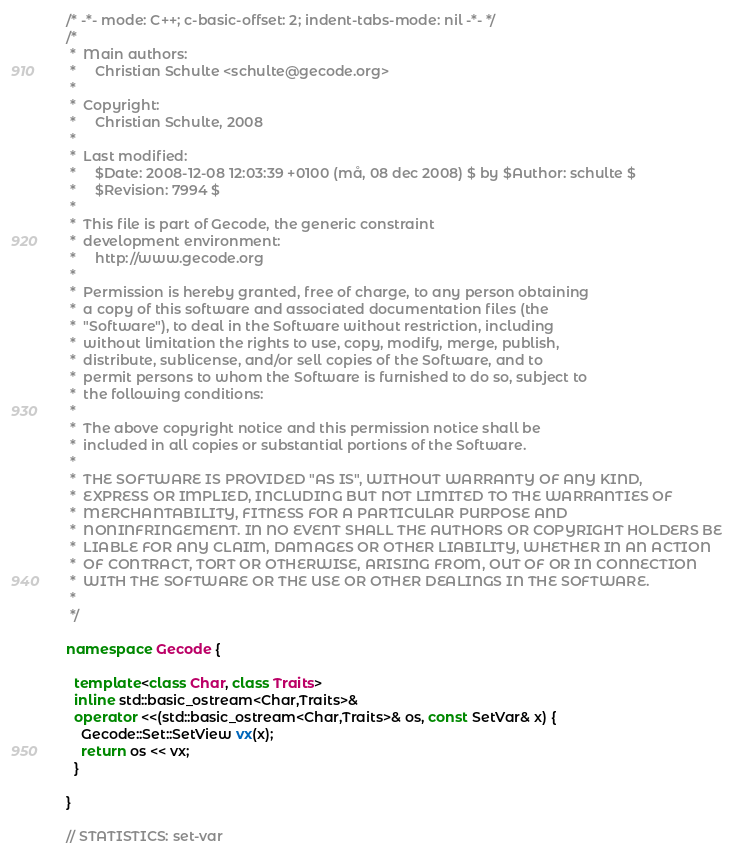<code> <loc_0><loc_0><loc_500><loc_500><_C++_>/* -*- mode: C++; c-basic-offset: 2; indent-tabs-mode: nil -*- */
/*
 *  Main authors:
 *     Christian Schulte <schulte@gecode.org>
 *
 *  Copyright:
 *     Christian Schulte, 2008
 *
 *  Last modified:
 *     $Date: 2008-12-08 12:03:39 +0100 (må, 08 dec 2008) $ by $Author: schulte $
 *     $Revision: 7994 $
 *
 *  This file is part of Gecode, the generic constraint
 *  development environment:
 *     http://www.gecode.org
 *
 *  Permission is hereby granted, free of charge, to any person obtaining
 *  a copy of this software and associated documentation files (the
 *  "Software"), to deal in the Software without restriction, including
 *  without limitation the rights to use, copy, modify, merge, publish,
 *  distribute, sublicense, and/or sell copies of the Software, and to
 *  permit persons to whom the Software is furnished to do so, subject to
 *  the following conditions:
 *
 *  The above copyright notice and this permission notice shall be
 *  included in all copies or substantial portions of the Software.
 *
 *  THE SOFTWARE IS PROVIDED "AS IS", WITHOUT WARRANTY OF ANY KIND,
 *  EXPRESS OR IMPLIED, INCLUDING BUT NOT LIMITED TO THE WARRANTIES OF
 *  MERCHANTABILITY, FITNESS FOR A PARTICULAR PURPOSE AND
 *  NONINFRINGEMENT. IN NO EVENT SHALL THE AUTHORS OR COPYRIGHT HOLDERS BE
 *  LIABLE FOR ANY CLAIM, DAMAGES OR OTHER LIABILITY, WHETHER IN AN ACTION
 *  OF CONTRACT, TORT OR OTHERWISE, ARISING FROM, OUT OF OR IN CONNECTION
 *  WITH THE SOFTWARE OR THE USE OR OTHER DEALINGS IN THE SOFTWARE.
 *
 */

namespace Gecode {

  template<class Char, class Traits>
  inline std::basic_ostream<Char,Traits>&
  operator <<(std::basic_ostream<Char,Traits>& os, const SetVar& x) {
    Gecode::Set::SetView vx(x);
    return os << vx;
  }

}

// STATISTICS: set-var
</code> 